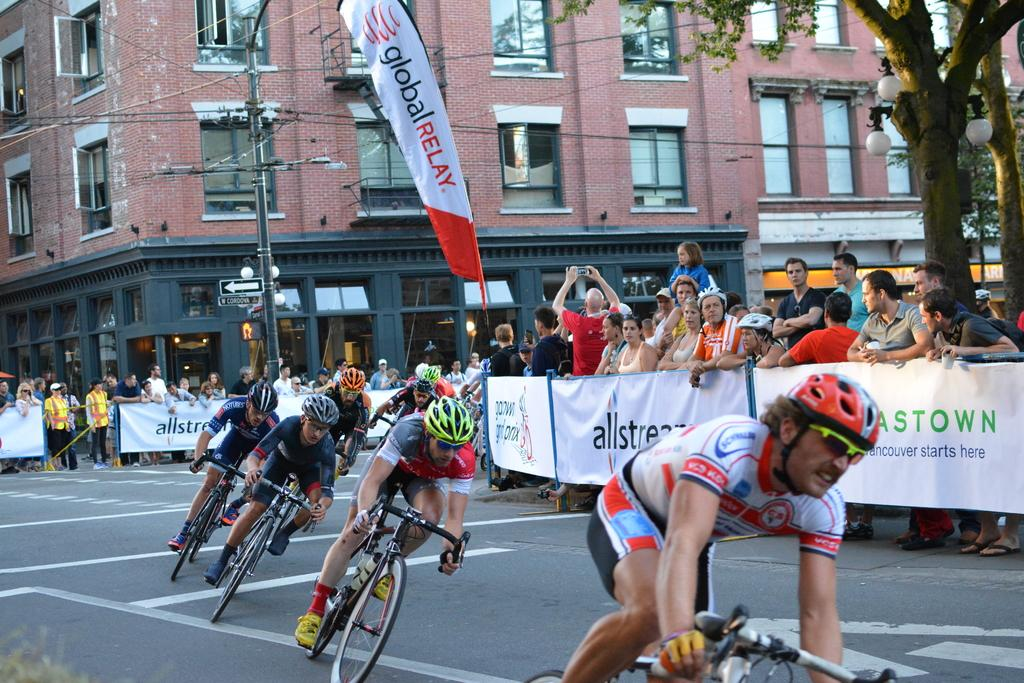How many people are in the image? There are people in the image, but the exact number is not specified. What are the people doing in the image? The people are standing and riding bicycles on the road. What safety precaution are the people taking while riding bicycles? The people are wearing helmets. What type of structure can be seen in the image? There is a building in the image. What architectural feature is present in the image? There is a glass window in the image. What is attached to the pole in the image? There are wires in the image. What type of decoration is present in the image? There are banners in the image. What type of illumination is present in the image? There are lights in the image. What type of vegetation is present in the image? There are trees in the image. What type of rice is being served in the image? There is no rice present in the image. What is the head of the person doing in the image? There is no specific action being performed by the head of the person in the image. 